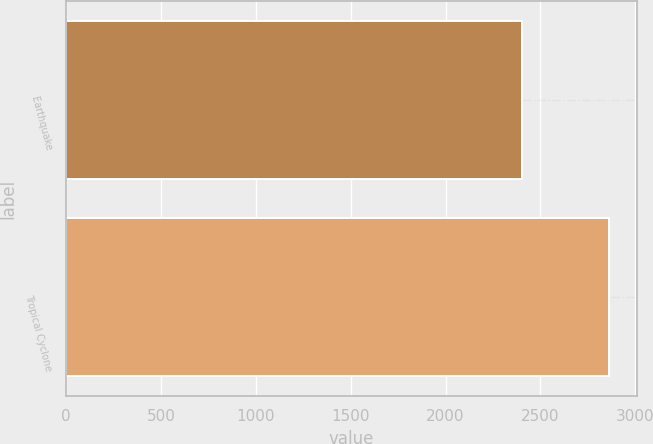Convert chart. <chart><loc_0><loc_0><loc_500><loc_500><bar_chart><fcel>Earthquake<fcel>Tropical Cyclone<nl><fcel>2402<fcel>2864<nl></chart> 